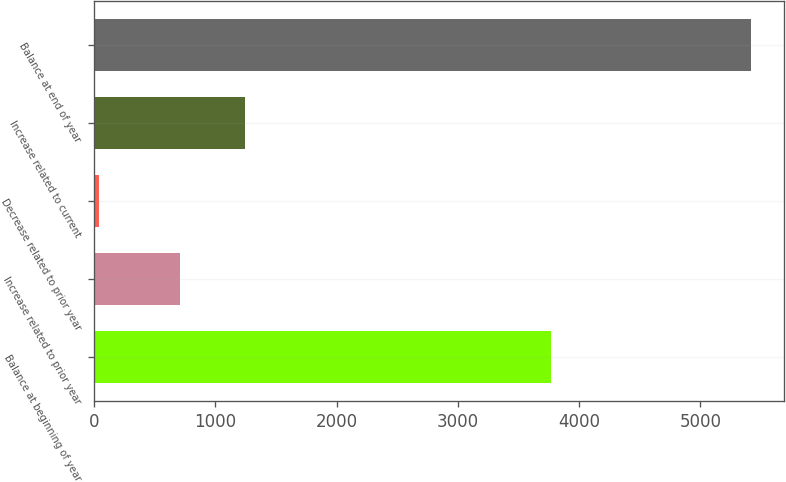<chart> <loc_0><loc_0><loc_500><loc_500><bar_chart><fcel>Balance at beginning of year<fcel>Increase related to prior year<fcel>Decrease related to prior year<fcel>Increase related to current<fcel>Balance at end of year<nl><fcel>3772<fcel>704<fcel>43<fcel>1241.4<fcel>5417<nl></chart> 